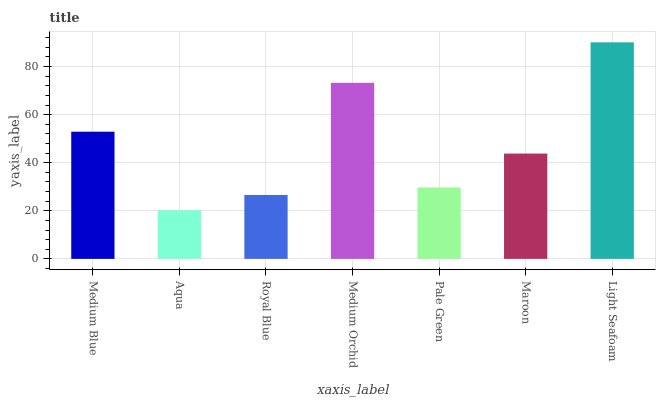Is Aqua the minimum?
Answer yes or no. Yes. Is Light Seafoam the maximum?
Answer yes or no. Yes. Is Royal Blue the minimum?
Answer yes or no. No. Is Royal Blue the maximum?
Answer yes or no. No. Is Royal Blue greater than Aqua?
Answer yes or no. Yes. Is Aqua less than Royal Blue?
Answer yes or no. Yes. Is Aqua greater than Royal Blue?
Answer yes or no. No. Is Royal Blue less than Aqua?
Answer yes or no. No. Is Maroon the high median?
Answer yes or no. Yes. Is Maroon the low median?
Answer yes or no. Yes. Is Aqua the high median?
Answer yes or no. No. Is Light Seafoam the low median?
Answer yes or no. No. 